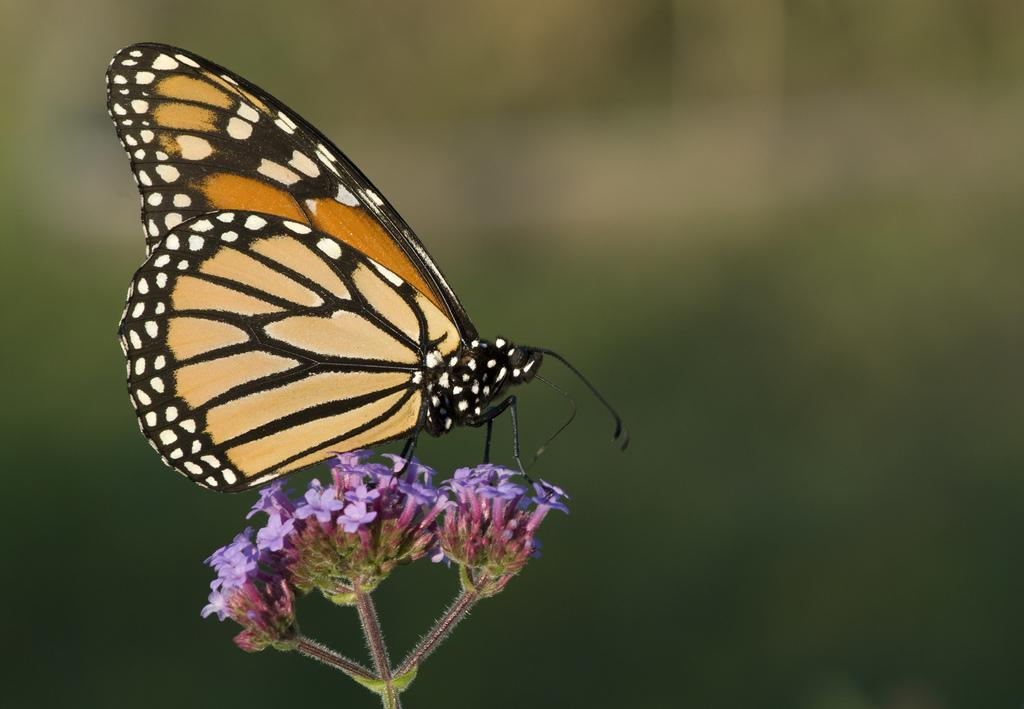What is the main subject of the image? There is a butterfly in the image. Where is the butterfly located in the image? The butterfly is on the flowers. How much money is the butterfly holding in the image? There is no money present in the image, as it features a butterfly on flowers. What type of star can be seen in the image? There is no star present in the image; it features a butterfly on flowers. 